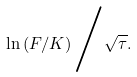Convert formula to latex. <formula><loc_0><loc_0><loc_500><loc_500>\ln \left ( F / K \right ) { \Big / } { \sqrt { \tau } } .</formula> 